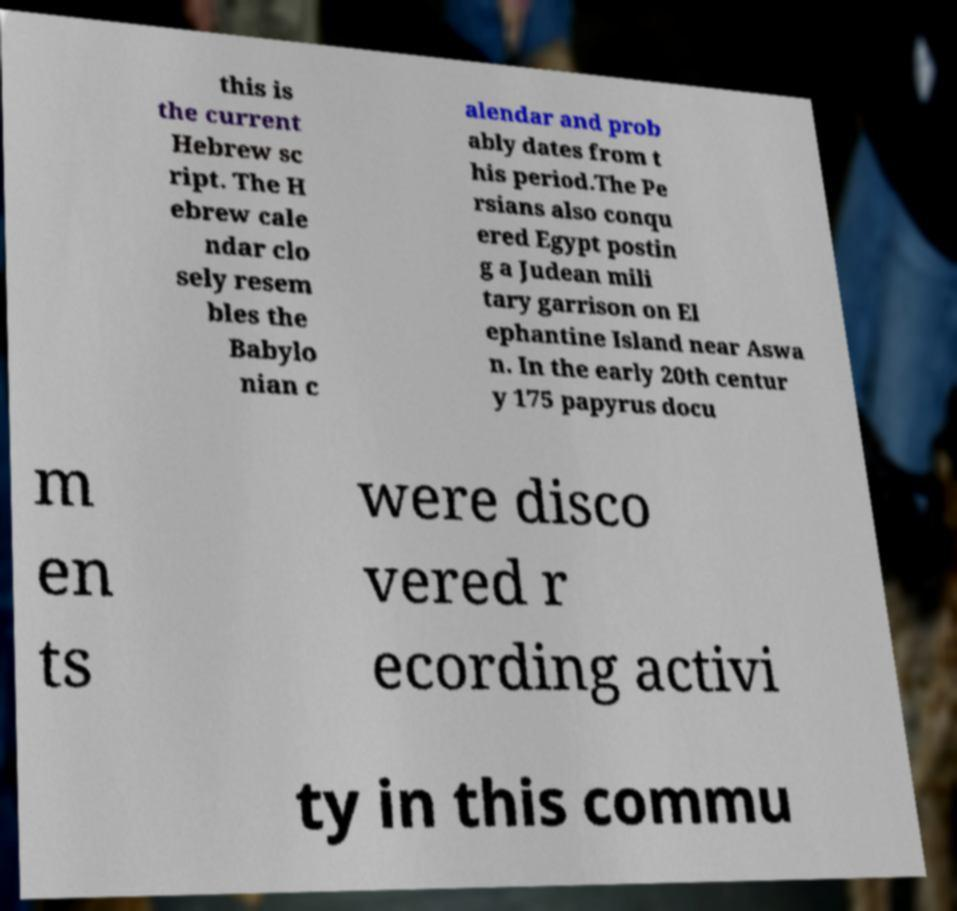Please identify and transcribe the text found in this image. this is the current Hebrew sc ript. The H ebrew cale ndar clo sely resem bles the Babylo nian c alendar and prob ably dates from t his period.The Pe rsians also conqu ered Egypt postin g a Judean mili tary garrison on El ephantine Island near Aswa n. In the early 20th centur y 175 papyrus docu m en ts were disco vered r ecording activi ty in this commu 